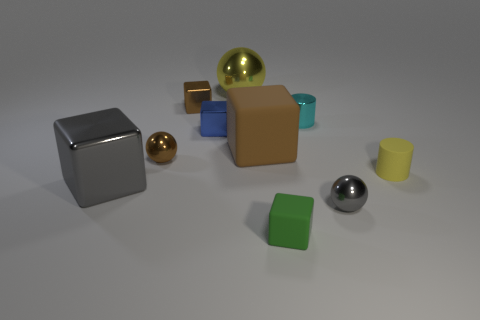There is a metallic object right of the cyan shiny cylinder; what size is it?
Your answer should be very brief. Small. There is a blue thing to the left of the brown block that is in front of the cyan metal thing; what size is it?
Keep it short and to the point. Small. There is a gray thing that is the same size as the blue shiny cube; what is it made of?
Provide a short and direct response. Metal. There is a big metal ball; are there any small green cubes on the left side of it?
Your answer should be compact. No. Is the number of gray shiny blocks behind the yellow metallic object the same as the number of small shiny objects?
Your answer should be compact. No. What is the shape of the gray metal object that is the same size as the brown matte cube?
Make the answer very short. Cube. What is the material of the brown ball?
Provide a short and direct response. Metal. What is the color of the rubber thing that is on the right side of the big brown rubber block and behind the green matte block?
Make the answer very short. Yellow. Are there an equal number of gray metal balls that are behind the small gray metallic object and tiny blocks that are behind the gray metallic cube?
Offer a very short reply. No. What is the color of the small cylinder that is made of the same material as the gray sphere?
Provide a succinct answer. Cyan. 